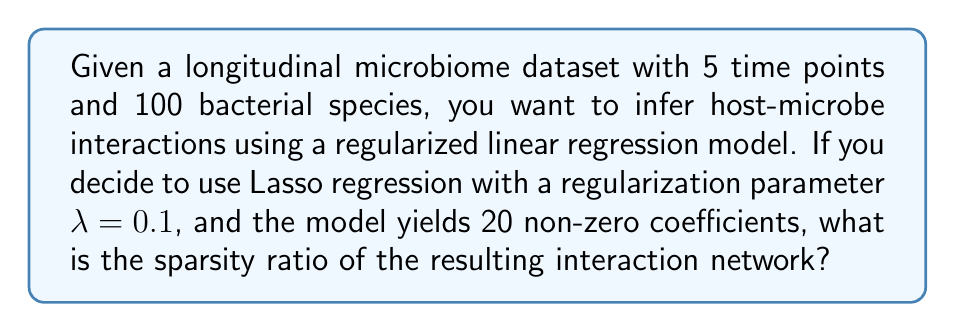Teach me how to tackle this problem. To solve this problem, we need to follow these steps:

1. Understand the dimensions of the problem:
   - Time points: 5
   - Bacterial species: 100

2. Calculate the total number of possible interactions:
   - In a fully connected network, each species can interact with every other species, including itself.
   - Total possible interactions = $100 \times 100 = 10,000$

3. Interpret the Lasso regression results:
   - Non-zero coefficients represent inferred interactions
   - Number of non-zero coefficients = 20

4. Calculate the sparsity ratio:
   - Sparsity ratio is the proportion of zero coefficients (non-interactions) in the model
   - Sparsity ratio = $\frac{\text{Number of zero coefficients}}{\text{Total possible interactions}}$
   - Number of zero coefficients = Total possible interactions - Non-zero coefficients
   - Number of zero coefficients = $10,000 - 20 = 9,980$
   - Sparsity ratio = $\frac{9,980}{10,000} = 0.998$

5. Convert to percentage:
   - Sparsity ratio percentage = $0.998 \times 100\% = 99.8\%$
Answer: 99.8% 